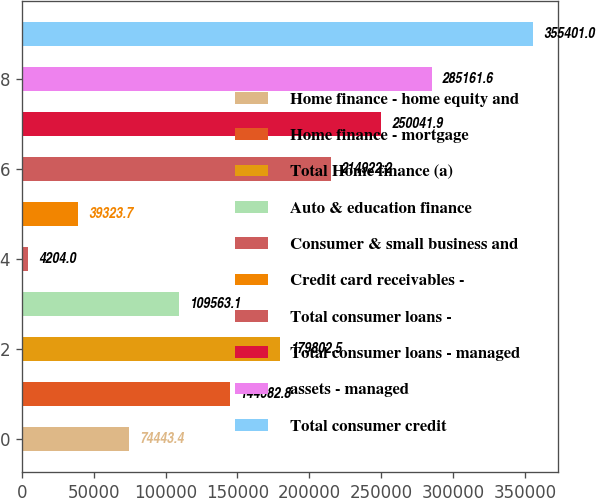Convert chart. <chart><loc_0><loc_0><loc_500><loc_500><bar_chart><fcel>Home finance - home equity and<fcel>Home finance - mortgage<fcel>Total Home finance (a)<fcel>Auto & education finance<fcel>Consumer & small business and<fcel>Credit card receivables -<fcel>Total consumer loans -<fcel>Total consumer loans - managed<fcel>assets - managed<fcel>Total consumer credit<nl><fcel>74443.4<fcel>144683<fcel>179802<fcel>109563<fcel>4204<fcel>39323.7<fcel>214922<fcel>250042<fcel>285162<fcel>355401<nl></chart> 